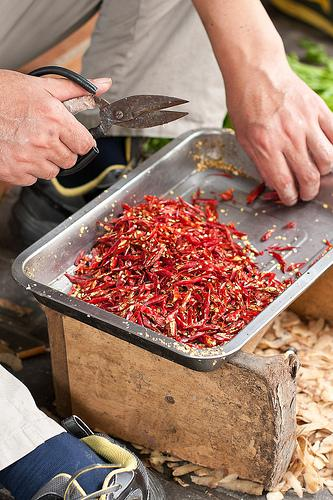Question: what is silver?
Choices:
A. A fork.
B. A ring.
C. A necklace.
D. A tray.
Answer with the letter. Answer: D Question: what is rectangle shaped?
Choices:
A. Black safe.
B. White file cabinet.
C. Silver tray.
D. Blue shoe box.
Answer with the letter. Answer: C Question: what is sharp?
Choices:
A. Scissors.
B. Knife.
C. Ice pick.
D. Needle.
Answer with the letter. Answer: A Question: where are scissors?
Choices:
A. On the end table.
B. On the office desk.
C. In a person's hand.
D. In the desk drawer.
Answer with the letter. Answer: C Question: who is holding scissors?
Choices:
A. A boy.
B. A girl.
C. A person.
D. A monkey.
Answer with the letter. Answer: C 